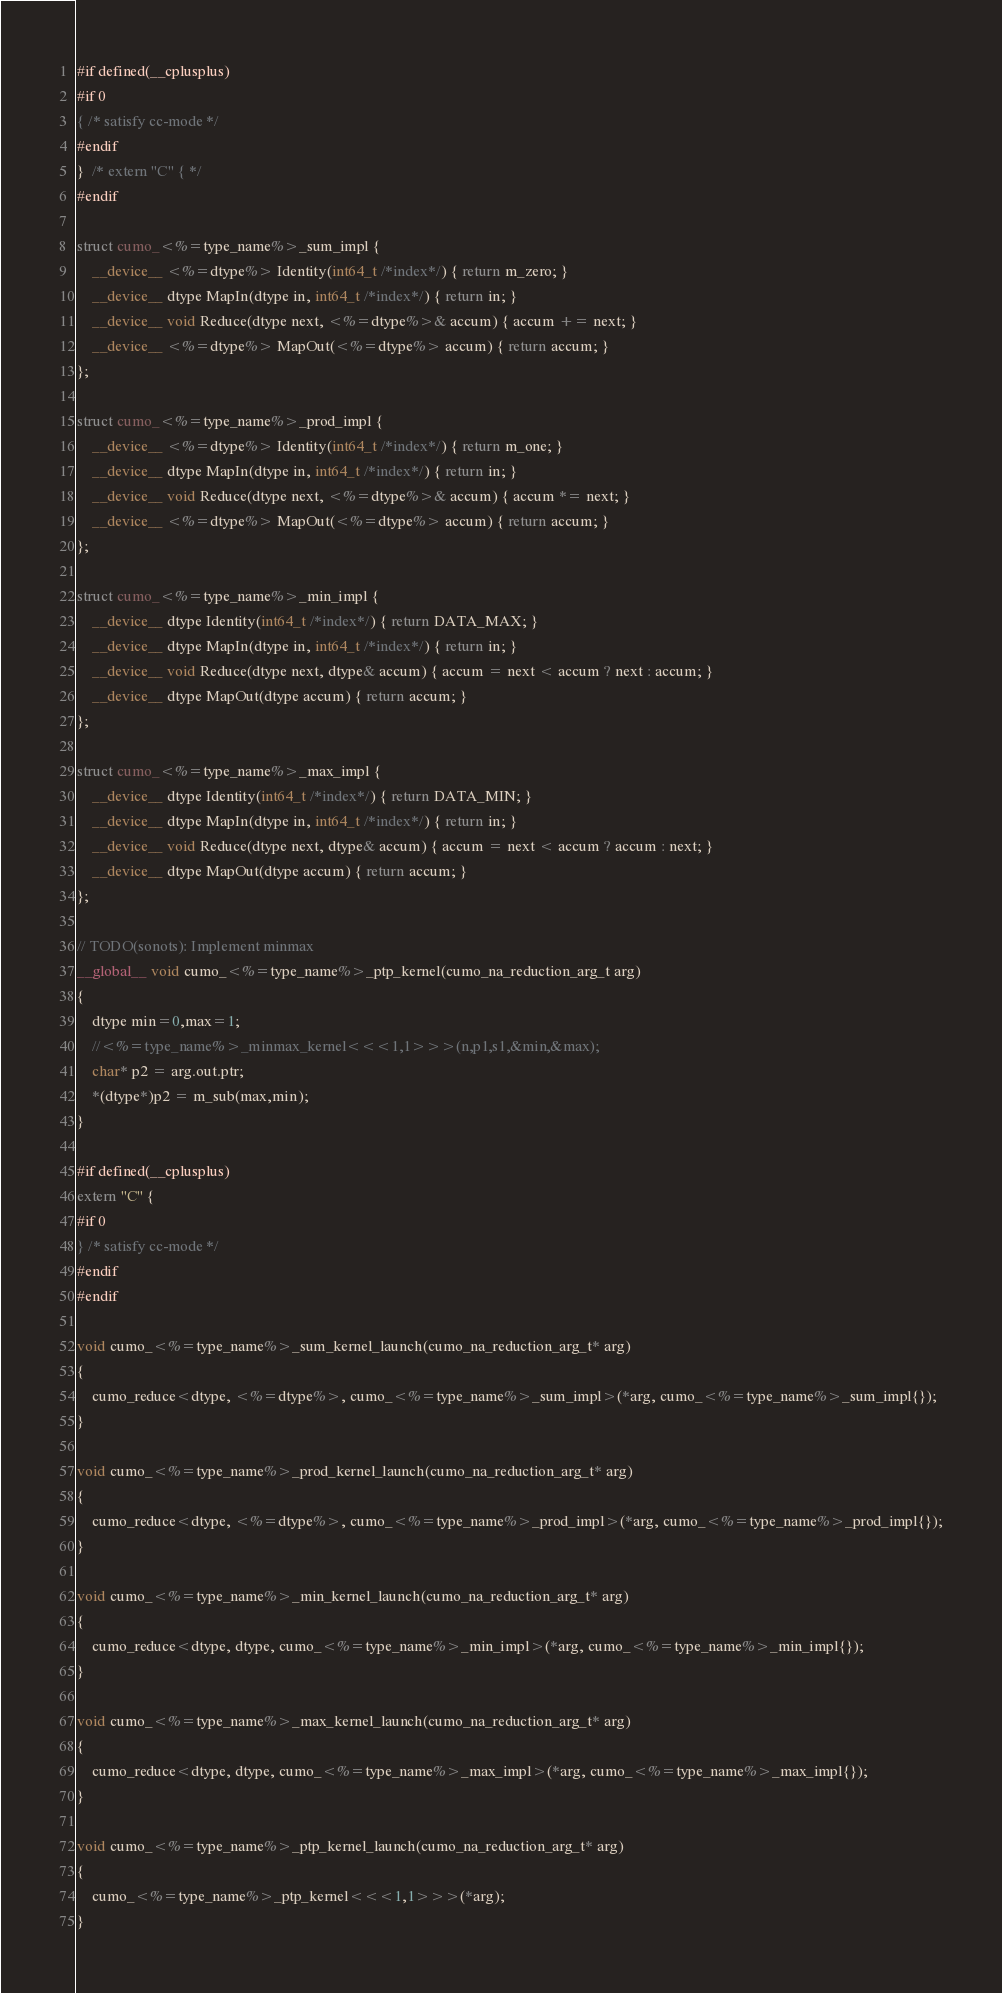Convert code to text. <code><loc_0><loc_0><loc_500><loc_500><_Cuda_>#if defined(__cplusplus)
#if 0
{ /* satisfy cc-mode */
#endif
}  /* extern "C" { */
#endif

struct cumo_<%=type_name%>_sum_impl {
    __device__ <%=dtype%> Identity(int64_t /*index*/) { return m_zero; }
    __device__ dtype MapIn(dtype in, int64_t /*index*/) { return in; }
    __device__ void Reduce(dtype next, <%=dtype%>& accum) { accum += next; }
    __device__ <%=dtype%> MapOut(<%=dtype%> accum) { return accum; }
};

struct cumo_<%=type_name%>_prod_impl {
    __device__ <%=dtype%> Identity(int64_t /*index*/) { return m_one; }
    __device__ dtype MapIn(dtype in, int64_t /*index*/) { return in; }
    __device__ void Reduce(dtype next, <%=dtype%>& accum) { accum *= next; }
    __device__ <%=dtype%> MapOut(<%=dtype%> accum) { return accum; }
};

struct cumo_<%=type_name%>_min_impl {
    __device__ dtype Identity(int64_t /*index*/) { return DATA_MAX; }
    __device__ dtype MapIn(dtype in, int64_t /*index*/) { return in; }
    __device__ void Reduce(dtype next, dtype& accum) { accum = next < accum ? next : accum; }
    __device__ dtype MapOut(dtype accum) { return accum; }
};

struct cumo_<%=type_name%>_max_impl {
    __device__ dtype Identity(int64_t /*index*/) { return DATA_MIN; }
    __device__ dtype MapIn(dtype in, int64_t /*index*/) { return in; }
    __device__ void Reduce(dtype next, dtype& accum) { accum = next < accum ? accum : next; }
    __device__ dtype MapOut(dtype accum) { return accum; }
};

// TODO(sonots): Implement minmax
__global__ void cumo_<%=type_name%>_ptp_kernel(cumo_na_reduction_arg_t arg)
{
    dtype min=0,max=1;
    //<%=type_name%>_minmax_kernel<<<1,1>>>(n,p1,s1,&min,&max);
    char* p2 = arg.out.ptr;
    *(dtype*)p2 = m_sub(max,min);
}

#if defined(__cplusplus)
extern "C" {
#if 0
} /* satisfy cc-mode */
#endif
#endif

void cumo_<%=type_name%>_sum_kernel_launch(cumo_na_reduction_arg_t* arg)
{
    cumo_reduce<dtype, <%=dtype%>, cumo_<%=type_name%>_sum_impl>(*arg, cumo_<%=type_name%>_sum_impl{});
}

void cumo_<%=type_name%>_prod_kernel_launch(cumo_na_reduction_arg_t* arg)
{
    cumo_reduce<dtype, <%=dtype%>, cumo_<%=type_name%>_prod_impl>(*arg, cumo_<%=type_name%>_prod_impl{});
}

void cumo_<%=type_name%>_min_kernel_launch(cumo_na_reduction_arg_t* arg)
{
    cumo_reduce<dtype, dtype, cumo_<%=type_name%>_min_impl>(*arg, cumo_<%=type_name%>_min_impl{});
}

void cumo_<%=type_name%>_max_kernel_launch(cumo_na_reduction_arg_t* arg)
{
    cumo_reduce<dtype, dtype, cumo_<%=type_name%>_max_impl>(*arg, cumo_<%=type_name%>_max_impl{});
}

void cumo_<%=type_name%>_ptp_kernel_launch(cumo_na_reduction_arg_t* arg)
{
    cumo_<%=type_name%>_ptp_kernel<<<1,1>>>(*arg);
}
</code> 